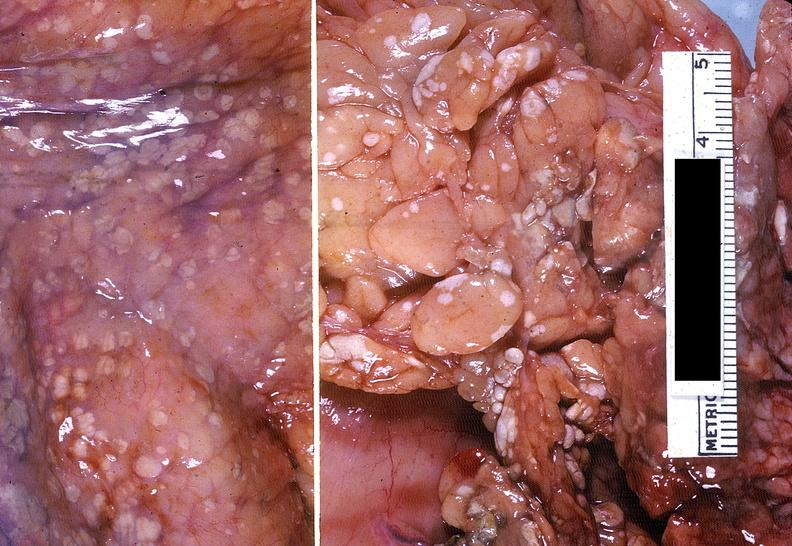what does this image show?
Answer the question using a single word or phrase. Acute pancreatitis with fat necrosis 